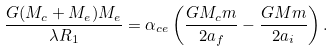<formula> <loc_0><loc_0><loc_500><loc_500>\frac { G ( M _ { c } + M _ { e } ) M _ { e } } { \lambda R _ { 1 } } = \alpha _ { c e } \left ( \frac { G M _ { c } m } { 2 a _ { f } } - \frac { G M m } { 2 a _ { i } } \right ) .</formula> 